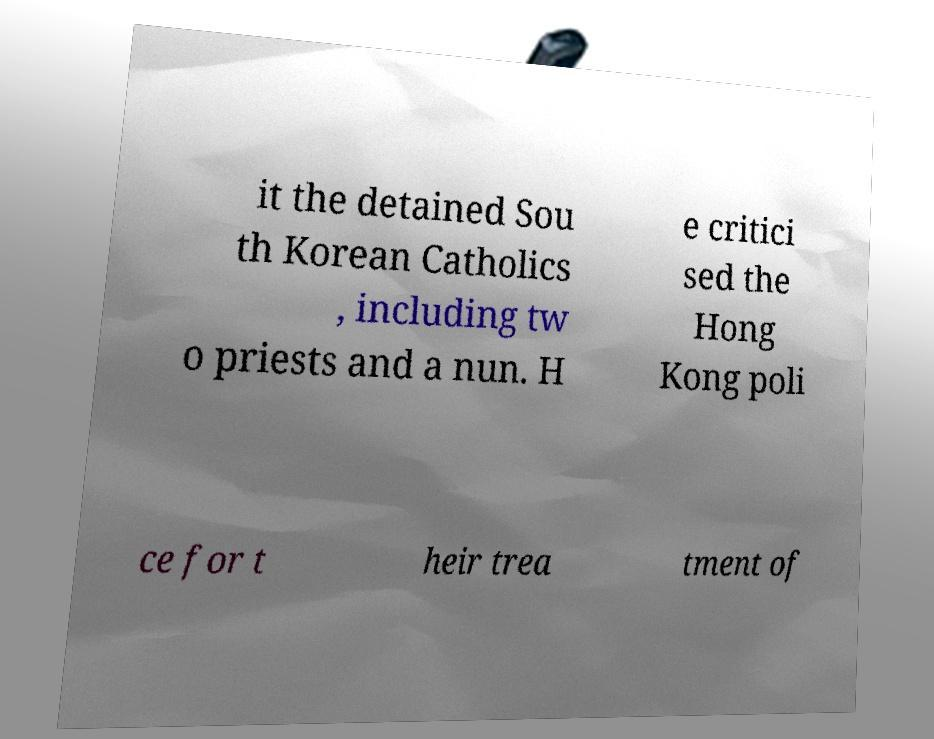Please identify and transcribe the text found in this image. it the detained Sou th Korean Catholics , including tw o priests and a nun. H e critici sed the Hong Kong poli ce for t heir trea tment of 